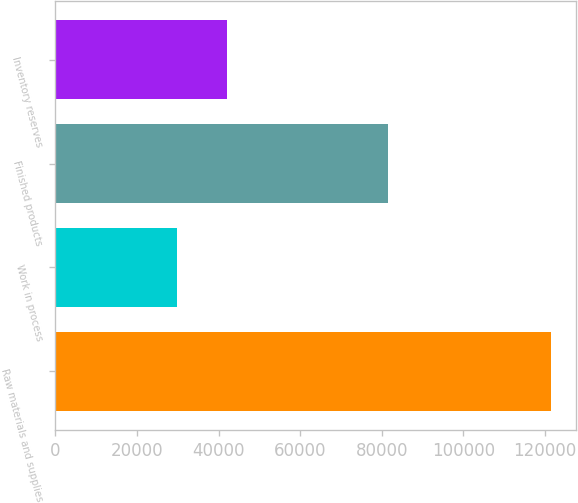Convert chart to OTSL. <chart><loc_0><loc_0><loc_500><loc_500><bar_chart><fcel>Raw materials and supplies<fcel>Work in process<fcel>Finished products<fcel>Inventory reserves<nl><fcel>121573<fcel>29725<fcel>81536<fcel>41967<nl></chart> 